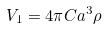<formula> <loc_0><loc_0><loc_500><loc_500>V _ { 1 } = 4 \pi C a ^ { 3 } \rho</formula> 